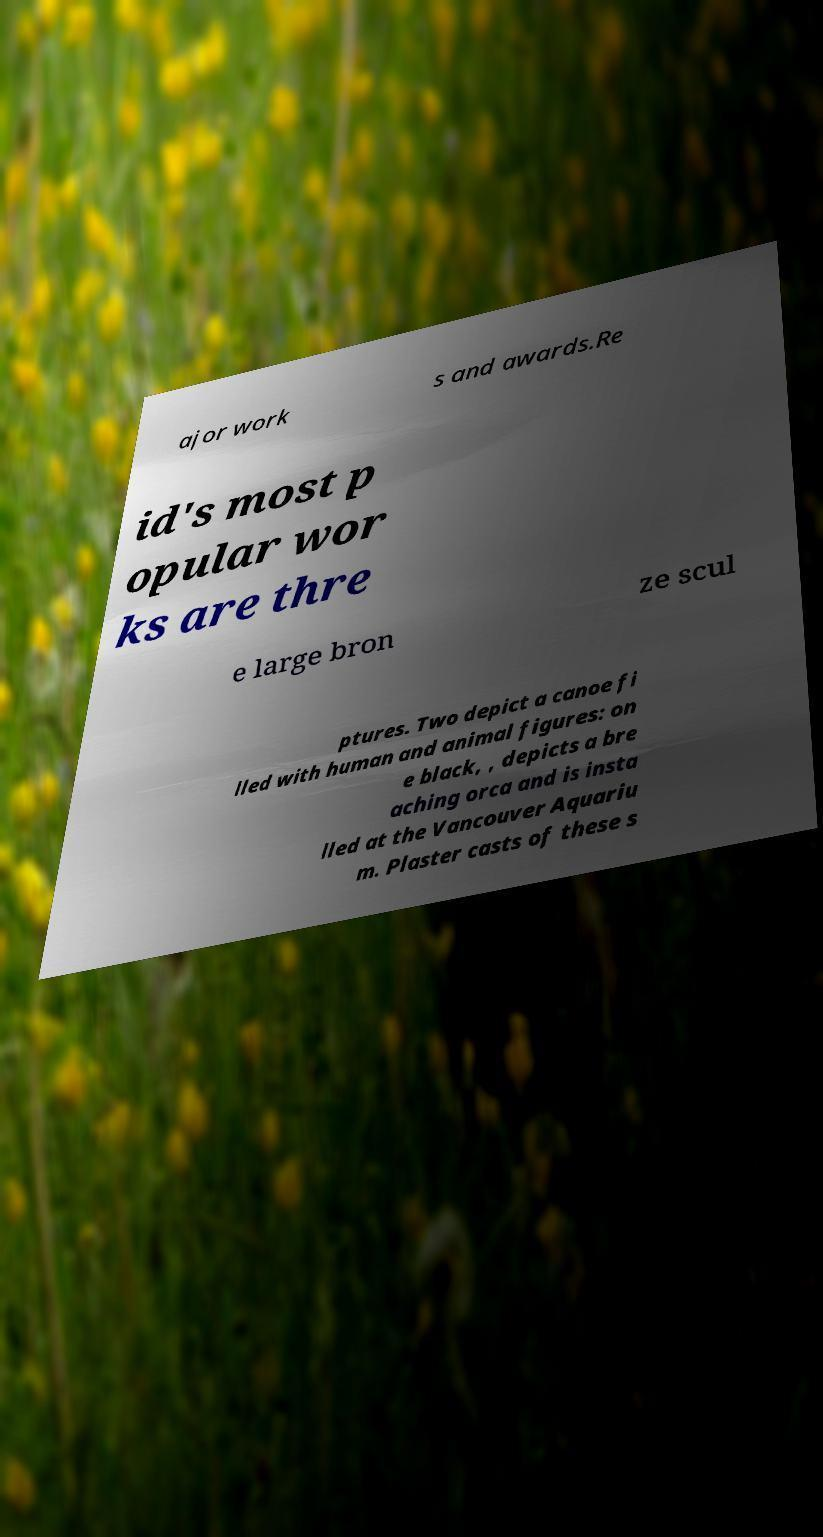Could you assist in decoding the text presented in this image and type it out clearly? ajor work s and awards.Re id's most p opular wor ks are thre e large bron ze scul ptures. Two depict a canoe fi lled with human and animal figures: on e black, , depicts a bre aching orca and is insta lled at the Vancouver Aquariu m. Plaster casts of these s 